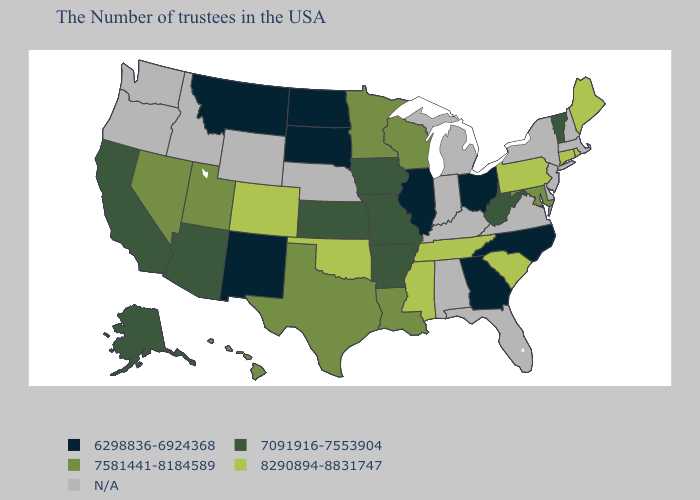What is the value of Georgia?
Write a very short answer. 6298836-6924368. Does North Carolina have the lowest value in the South?
Quick response, please. Yes. Which states have the highest value in the USA?
Quick response, please. Maine, Rhode Island, Connecticut, Pennsylvania, South Carolina, Tennessee, Mississippi, Oklahoma, Colorado. Name the states that have a value in the range 7091916-7553904?
Answer briefly. Vermont, West Virginia, Missouri, Arkansas, Iowa, Kansas, Arizona, California, Alaska. What is the highest value in states that border Utah?
Answer briefly. 8290894-8831747. Does the map have missing data?
Short answer required. Yes. Name the states that have a value in the range N/A?
Keep it brief. Massachusetts, New Hampshire, New York, New Jersey, Delaware, Virginia, Florida, Michigan, Kentucky, Indiana, Alabama, Nebraska, Wyoming, Idaho, Washington, Oregon. Does Connecticut have the highest value in the USA?
Be succinct. Yes. Is the legend a continuous bar?
Concise answer only. No. Does Mississippi have the lowest value in the South?
Be succinct. No. Among the states that border Arizona , which have the highest value?
Keep it brief. Colorado. What is the value of New Hampshire?
Short answer required. N/A. Does the first symbol in the legend represent the smallest category?
Quick response, please. Yes. 